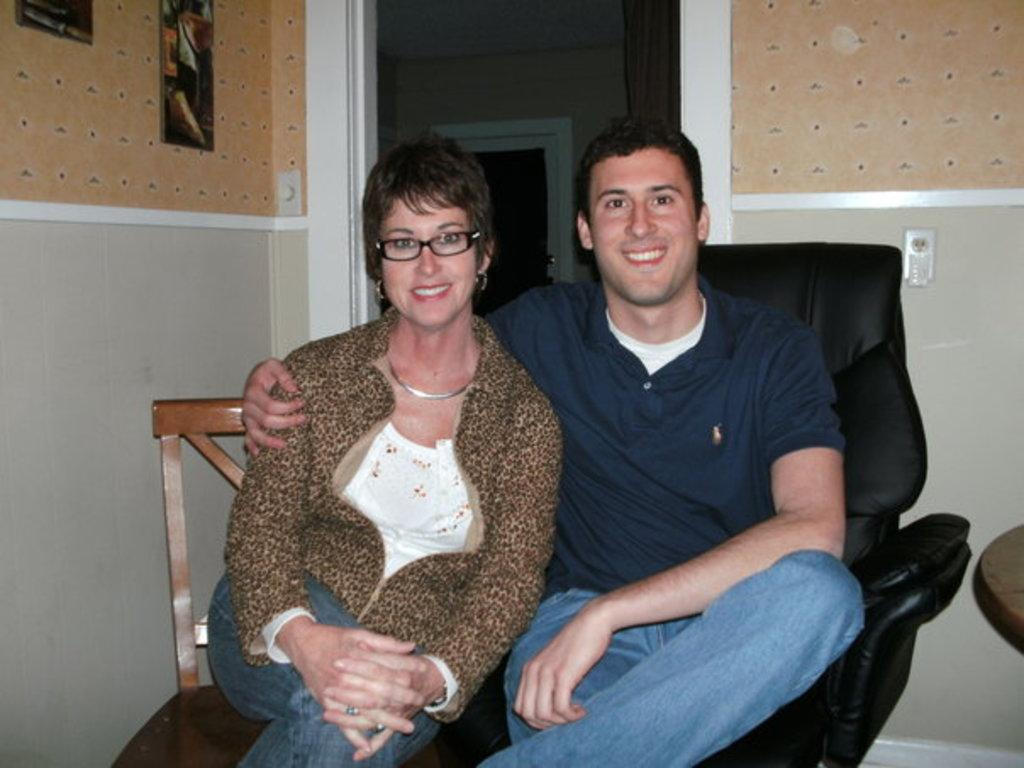Who can be seen in the image? There is a man and a woman in the image. What are the man and woman doing in the image? The man and woman are sitting on chairs. What can be seen in the background of the image? There is a door, a curtain, and a wall in the background of the image. How many geese are present in the image? There are no geese present in the image. What type of toys can be seen on the floor in the image? There is no mention of toys or a floor in the image; it only features a man, a woman, and the background elements. 